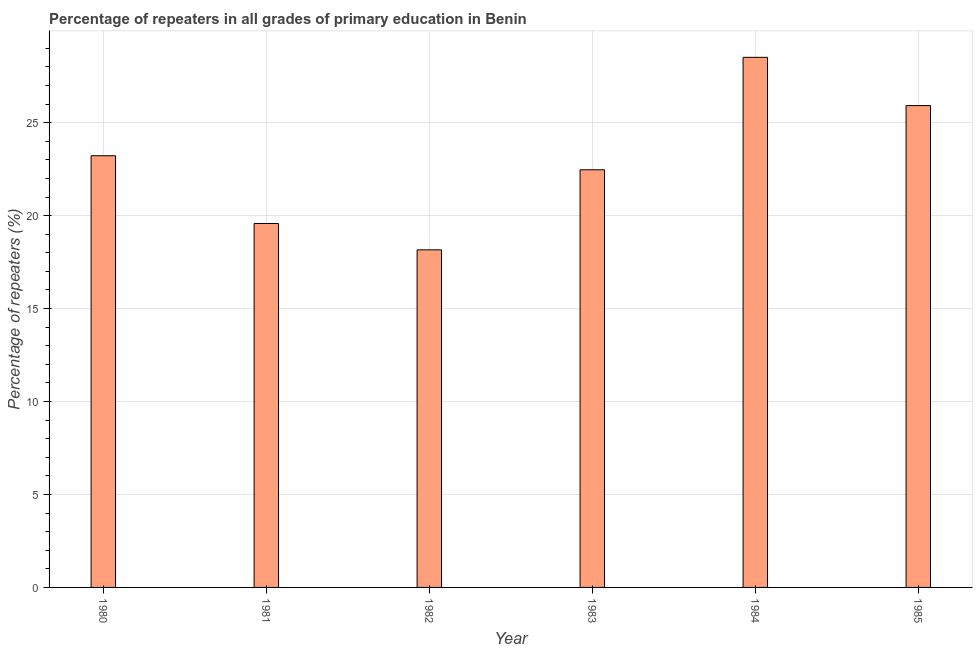What is the title of the graph?
Your answer should be very brief. Percentage of repeaters in all grades of primary education in Benin. What is the label or title of the Y-axis?
Ensure brevity in your answer.  Percentage of repeaters (%). What is the percentage of repeaters in primary education in 1983?
Keep it short and to the point. 22.47. Across all years, what is the maximum percentage of repeaters in primary education?
Offer a very short reply. 28.52. Across all years, what is the minimum percentage of repeaters in primary education?
Offer a terse response. 18.16. In which year was the percentage of repeaters in primary education minimum?
Make the answer very short. 1982. What is the sum of the percentage of repeaters in primary education?
Make the answer very short. 137.86. What is the difference between the percentage of repeaters in primary education in 1981 and 1985?
Ensure brevity in your answer.  -6.34. What is the average percentage of repeaters in primary education per year?
Make the answer very short. 22.98. What is the median percentage of repeaters in primary education?
Ensure brevity in your answer.  22.84. In how many years, is the percentage of repeaters in primary education greater than 23 %?
Make the answer very short. 3. What is the ratio of the percentage of repeaters in primary education in 1981 to that in 1982?
Provide a succinct answer. 1.08. Is the difference between the percentage of repeaters in primary education in 1983 and 1984 greater than the difference between any two years?
Your answer should be compact. No. What is the difference between the highest and the second highest percentage of repeaters in primary education?
Your response must be concise. 2.6. Is the sum of the percentage of repeaters in primary education in 1981 and 1984 greater than the maximum percentage of repeaters in primary education across all years?
Your answer should be very brief. Yes. What is the difference between the highest and the lowest percentage of repeaters in primary education?
Give a very brief answer. 10.36. In how many years, is the percentage of repeaters in primary education greater than the average percentage of repeaters in primary education taken over all years?
Your answer should be very brief. 3. How many bars are there?
Keep it short and to the point. 6. Are the values on the major ticks of Y-axis written in scientific E-notation?
Keep it short and to the point. No. What is the Percentage of repeaters (%) of 1980?
Your answer should be compact. 23.22. What is the Percentage of repeaters (%) in 1981?
Provide a short and direct response. 19.58. What is the Percentage of repeaters (%) of 1982?
Ensure brevity in your answer.  18.16. What is the Percentage of repeaters (%) in 1983?
Provide a succinct answer. 22.47. What is the Percentage of repeaters (%) in 1984?
Keep it short and to the point. 28.52. What is the Percentage of repeaters (%) in 1985?
Offer a terse response. 25.92. What is the difference between the Percentage of repeaters (%) in 1980 and 1981?
Your response must be concise. 3.64. What is the difference between the Percentage of repeaters (%) in 1980 and 1982?
Your answer should be very brief. 5.06. What is the difference between the Percentage of repeaters (%) in 1980 and 1983?
Provide a short and direct response. 0.75. What is the difference between the Percentage of repeaters (%) in 1980 and 1984?
Your answer should be compact. -5.29. What is the difference between the Percentage of repeaters (%) in 1980 and 1985?
Keep it short and to the point. -2.7. What is the difference between the Percentage of repeaters (%) in 1981 and 1982?
Provide a short and direct response. 1.42. What is the difference between the Percentage of repeaters (%) in 1981 and 1983?
Your response must be concise. -2.89. What is the difference between the Percentage of repeaters (%) in 1981 and 1984?
Offer a terse response. -8.94. What is the difference between the Percentage of repeaters (%) in 1981 and 1985?
Offer a terse response. -6.34. What is the difference between the Percentage of repeaters (%) in 1982 and 1983?
Keep it short and to the point. -4.31. What is the difference between the Percentage of repeaters (%) in 1982 and 1984?
Offer a terse response. -10.36. What is the difference between the Percentage of repeaters (%) in 1982 and 1985?
Offer a terse response. -7.76. What is the difference between the Percentage of repeaters (%) in 1983 and 1984?
Your answer should be compact. -6.05. What is the difference between the Percentage of repeaters (%) in 1983 and 1985?
Ensure brevity in your answer.  -3.45. What is the difference between the Percentage of repeaters (%) in 1984 and 1985?
Your response must be concise. 2.6. What is the ratio of the Percentage of repeaters (%) in 1980 to that in 1981?
Give a very brief answer. 1.19. What is the ratio of the Percentage of repeaters (%) in 1980 to that in 1982?
Offer a terse response. 1.28. What is the ratio of the Percentage of repeaters (%) in 1980 to that in 1983?
Provide a succinct answer. 1.03. What is the ratio of the Percentage of repeaters (%) in 1980 to that in 1984?
Make the answer very short. 0.81. What is the ratio of the Percentage of repeaters (%) in 1980 to that in 1985?
Offer a very short reply. 0.9. What is the ratio of the Percentage of repeaters (%) in 1981 to that in 1982?
Make the answer very short. 1.08. What is the ratio of the Percentage of repeaters (%) in 1981 to that in 1983?
Provide a succinct answer. 0.87. What is the ratio of the Percentage of repeaters (%) in 1981 to that in 1984?
Keep it short and to the point. 0.69. What is the ratio of the Percentage of repeaters (%) in 1981 to that in 1985?
Offer a very short reply. 0.76. What is the ratio of the Percentage of repeaters (%) in 1982 to that in 1983?
Offer a terse response. 0.81. What is the ratio of the Percentage of repeaters (%) in 1982 to that in 1984?
Your response must be concise. 0.64. What is the ratio of the Percentage of repeaters (%) in 1982 to that in 1985?
Offer a very short reply. 0.7. What is the ratio of the Percentage of repeaters (%) in 1983 to that in 1984?
Provide a short and direct response. 0.79. What is the ratio of the Percentage of repeaters (%) in 1983 to that in 1985?
Give a very brief answer. 0.87. 